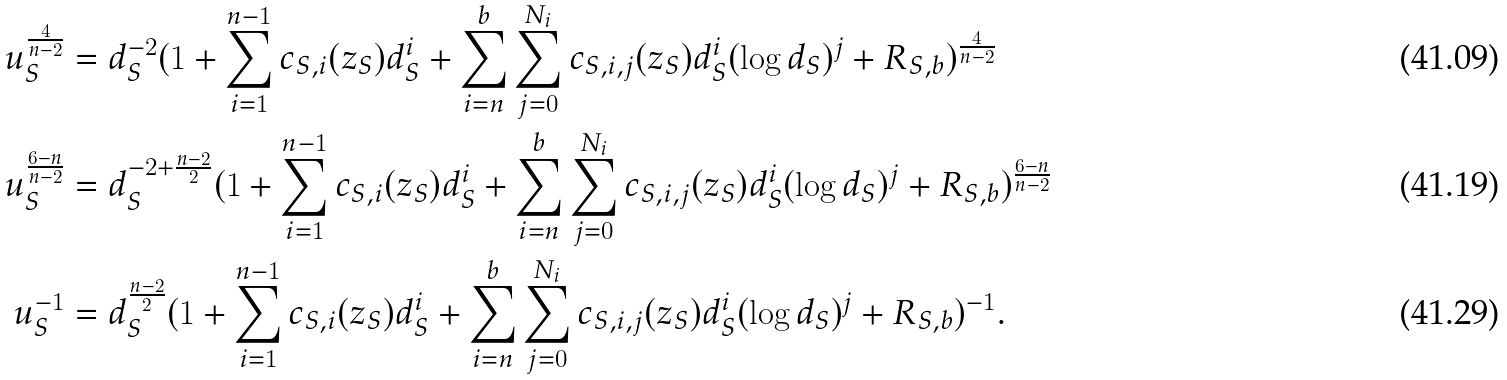<formula> <loc_0><loc_0><loc_500><loc_500>u _ { S } ^ { \frac { 4 } { n - 2 } } & = d _ { S } ^ { - 2 } ( 1 + \sum _ { i = 1 } ^ { n - 1 } c _ { S , i } ( z _ { S } ) d _ { S } ^ { i } + \sum _ { i = n } ^ { b } \sum _ { j = 0 } ^ { N _ { i } } c _ { S , i , j } ( z _ { S } ) d _ { S } ^ { i } ( \log d _ { S } ) ^ { j } + R _ { S , b } ) ^ { \frac { 4 } { n - 2 } } \\ u _ { S } ^ { \frac { 6 - n } { n - 2 } } & = d _ { S } ^ { - 2 + \frac { n - 2 } { 2 } } ( 1 + \sum _ { i = 1 } ^ { n - 1 } c _ { S , i } ( z _ { S } ) d _ { S } ^ { i } + \sum _ { i = n } ^ { b } \sum _ { j = 0 } ^ { N _ { i } } c _ { S , i , j } ( z _ { S } ) d _ { S } ^ { i } ( \log d _ { S } ) ^ { j } + R _ { S , b } ) ^ { \frac { 6 - n } { n - 2 } } \\ u _ { S } ^ { - 1 } & = d _ { S } ^ { \frac { n - 2 } { 2 } } ( 1 + \sum _ { i = 1 } ^ { n - 1 } c _ { S , i } ( z _ { S } ) d _ { S } ^ { i } + \sum _ { i = n } ^ { b } \sum _ { j = 0 } ^ { N _ { i } } c _ { S , i , j } ( z _ { S } ) d _ { S } ^ { i } ( \log d _ { S } ) ^ { j } + R _ { S , b } ) ^ { - 1 } .</formula> 